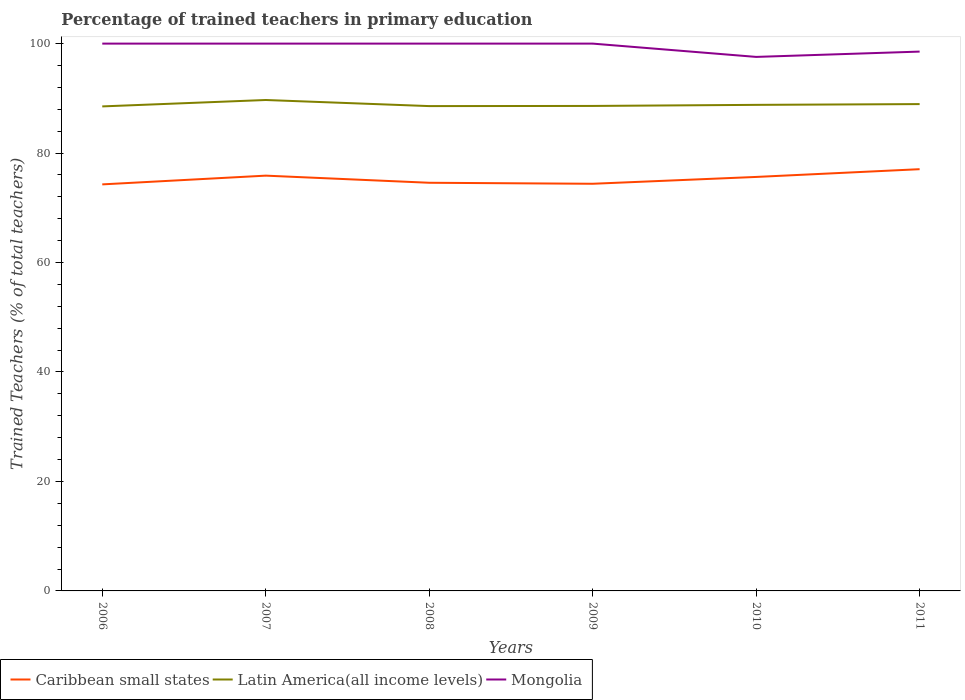Does the line corresponding to Latin America(all income levels) intersect with the line corresponding to Mongolia?
Make the answer very short. No. Across all years, what is the maximum percentage of trained teachers in Latin America(all income levels)?
Give a very brief answer. 88.53. What is the total percentage of trained teachers in Caribbean small states in the graph?
Your answer should be very brief. -1.6. What is the difference between the highest and the second highest percentage of trained teachers in Mongolia?
Ensure brevity in your answer.  2.43. Is the percentage of trained teachers in Latin America(all income levels) strictly greater than the percentage of trained teachers in Mongolia over the years?
Your response must be concise. Yes. How many lines are there?
Provide a succinct answer. 3. How many years are there in the graph?
Make the answer very short. 6. What is the difference between two consecutive major ticks on the Y-axis?
Make the answer very short. 20. Does the graph contain any zero values?
Your answer should be compact. No. How many legend labels are there?
Your answer should be very brief. 3. How are the legend labels stacked?
Your answer should be compact. Horizontal. What is the title of the graph?
Offer a very short reply. Percentage of trained teachers in primary education. Does "Bulgaria" appear as one of the legend labels in the graph?
Your response must be concise. No. What is the label or title of the Y-axis?
Ensure brevity in your answer.  Trained Teachers (% of total teachers). What is the Trained Teachers (% of total teachers) in Caribbean small states in 2006?
Provide a succinct answer. 74.28. What is the Trained Teachers (% of total teachers) of Latin America(all income levels) in 2006?
Provide a succinct answer. 88.53. What is the Trained Teachers (% of total teachers) in Caribbean small states in 2007?
Give a very brief answer. 75.88. What is the Trained Teachers (% of total teachers) in Latin America(all income levels) in 2007?
Your response must be concise. 89.7. What is the Trained Teachers (% of total teachers) in Caribbean small states in 2008?
Provide a succinct answer. 74.57. What is the Trained Teachers (% of total teachers) in Latin America(all income levels) in 2008?
Provide a short and direct response. 88.58. What is the Trained Teachers (% of total teachers) of Mongolia in 2008?
Your answer should be very brief. 100. What is the Trained Teachers (% of total teachers) of Caribbean small states in 2009?
Provide a short and direct response. 74.39. What is the Trained Teachers (% of total teachers) of Latin America(all income levels) in 2009?
Ensure brevity in your answer.  88.61. What is the Trained Teachers (% of total teachers) of Caribbean small states in 2010?
Provide a succinct answer. 75.64. What is the Trained Teachers (% of total teachers) of Latin America(all income levels) in 2010?
Provide a succinct answer. 88.81. What is the Trained Teachers (% of total teachers) in Mongolia in 2010?
Ensure brevity in your answer.  97.57. What is the Trained Teachers (% of total teachers) in Caribbean small states in 2011?
Your answer should be very brief. 77.06. What is the Trained Teachers (% of total teachers) of Latin America(all income levels) in 2011?
Your answer should be very brief. 88.95. What is the Trained Teachers (% of total teachers) in Mongolia in 2011?
Your answer should be compact. 98.54. Across all years, what is the maximum Trained Teachers (% of total teachers) in Caribbean small states?
Offer a terse response. 77.06. Across all years, what is the maximum Trained Teachers (% of total teachers) of Latin America(all income levels)?
Provide a short and direct response. 89.7. Across all years, what is the maximum Trained Teachers (% of total teachers) of Mongolia?
Provide a succinct answer. 100. Across all years, what is the minimum Trained Teachers (% of total teachers) of Caribbean small states?
Give a very brief answer. 74.28. Across all years, what is the minimum Trained Teachers (% of total teachers) of Latin America(all income levels)?
Provide a succinct answer. 88.53. Across all years, what is the minimum Trained Teachers (% of total teachers) of Mongolia?
Your answer should be very brief. 97.57. What is the total Trained Teachers (% of total teachers) of Caribbean small states in the graph?
Offer a terse response. 451.82. What is the total Trained Teachers (% of total teachers) of Latin America(all income levels) in the graph?
Your answer should be very brief. 533.18. What is the total Trained Teachers (% of total teachers) in Mongolia in the graph?
Ensure brevity in your answer.  596.11. What is the difference between the Trained Teachers (% of total teachers) of Caribbean small states in 2006 and that in 2007?
Provide a short and direct response. -1.6. What is the difference between the Trained Teachers (% of total teachers) of Latin America(all income levels) in 2006 and that in 2007?
Give a very brief answer. -1.17. What is the difference between the Trained Teachers (% of total teachers) in Mongolia in 2006 and that in 2007?
Make the answer very short. 0. What is the difference between the Trained Teachers (% of total teachers) of Caribbean small states in 2006 and that in 2008?
Your answer should be compact. -0.29. What is the difference between the Trained Teachers (% of total teachers) of Latin America(all income levels) in 2006 and that in 2008?
Give a very brief answer. -0.05. What is the difference between the Trained Teachers (% of total teachers) of Mongolia in 2006 and that in 2008?
Provide a short and direct response. 0. What is the difference between the Trained Teachers (% of total teachers) in Caribbean small states in 2006 and that in 2009?
Ensure brevity in your answer.  -0.11. What is the difference between the Trained Teachers (% of total teachers) in Latin America(all income levels) in 2006 and that in 2009?
Provide a short and direct response. -0.08. What is the difference between the Trained Teachers (% of total teachers) of Caribbean small states in 2006 and that in 2010?
Ensure brevity in your answer.  -1.36. What is the difference between the Trained Teachers (% of total teachers) of Latin America(all income levels) in 2006 and that in 2010?
Your answer should be compact. -0.28. What is the difference between the Trained Teachers (% of total teachers) in Mongolia in 2006 and that in 2010?
Provide a succinct answer. 2.43. What is the difference between the Trained Teachers (% of total teachers) in Caribbean small states in 2006 and that in 2011?
Keep it short and to the point. -2.78. What is the difference between the Trained Teachers (% of total teachers) of Latin America(all income levels) in 2006 and that in 2011?
Provide a succinct answer. -0.42. What is the difference between the Trained Teachers (% of total teachers) of Mongolia in 2006 and that in 2011?
Offer a very short reply. 1.46. What is the difference between the Trained Teachers (% of total teachers) of Caribbean small states in 2007 and that in 2008?
Make the answer very short. 1.3. What is the difference between the Trained Teachers (% of total teachers) in Latin America(all income levels) in 2007 and that in 2008?
Your answer should be compact. 1.11. What is the difference between the Trained Teachers (% of total teachers) in Mongolia in 2007 and that in 2008?
Provide a short and direct response. 0. What is the difference between the Trained Teachers (% of total teachers) of Caribbean small states in 2007 and that in 2009?
Ensure brevity in your answer.  1.48. What is the difference between the Trained Teachers (% of total teachers) of Latin America(all income levels) in 2007 and that in 2009?
Offer a very short reply. 1.08. What is the difference between the Trained Teachers (% of total teachers) in Mongolia in 2007 and that in 2009?
Your answer should be compact. 0. What is the difference between the Trained Teachers (% of total teachers) of Caribbean small states in 2007 and that in 2010?
Your answer should be very brief. 0.24. What is the difference between the Trained Teachers (% of total teachers) in Latin America(all income levels) in 2007 and that in 2010?
Ensure brevity in your answer.  0.89. What is the difference between the Trained Teachers (% of total teachers) of Mongolia in 2007 and that in 2010?
Offer a very short reply. 2.43. What is the difference between the Trained Teachers (% of total teachers) of Caribbean small states in 2007 and that in 2011?
Keep it short and to the point. -1.18. What is the difference between the Trained Teachers (% of total teachers) of Latin America(all income levels) in 2007 and that in 2011?
Your answer should be very brief. 0.75. What is the difference between the Trained Teachers (% of total teachers) of Mongolia in 2007 and that in 2011?
Make the answer very short. 1.46. What is the difference between the Trained Teachers (% of total teachers) in Caribbean small states in 2008 and that in 2009?
Offer a very short reply. 0.18. What is the difference between the Trained Teachers (% of total teachers) in Latin America(all income levels) in 2008 and that in 2009?
Give a very brief answer. -0.03. What is the difference between the Trained Teachers (% of total teachers) in Caribbean small states in 2008 and that in 2010?
Make the answer very short. -1.06. What is the difference between the Trained Teachers (% of total teachers) of Latin America(all income levels) in 2008 and that in 2010?
Make the answer very short. -0.23. What is the difference between the Trained Teachers (% of total teachers) of Mongolia in 2008 and that in 2010?
Offer a terse response. 2.43. What is the difference between the Trained Teachers (% of total teachers) in Caribbean small states in 2008 and that in 2011?
Your answer should be compact. -2.48. What is the difference between the Trained Teachers (% of total teachers) of Latin America(all income levels) in 2008 and that in 2011?
Your response must be concise. -0.37. What is the difference between the Trained Teachers (% of total teachers) in Mongolia in 2008 and that in 2011?
Provide a succinct answer. 1.46. What is the difference between the Trained Teachers (% of total teachers) in Caribbean small states in 2009 and that in 2010?
Your response must be concise. -1.25. What is the difference between the Trained Teachers (% of total teachers) of Latin America(all income levels) in 2009 and that in 2010?
Your response must be concise. -0.2. What is the difference between the Trained Teachers (% of total teachers) in Mongolia in 2009 and that in 2010?
Provide a short and direct response. 2.43. What is the difference between the Trained Teachers (% of total teachers) in Caribbean small states in 2009 and that in 2011?
Provide a succinct answer. -2.66. What is the difference between the Trained Teachers (% of total teachers) in Latin America(all income levels) in 2009 and that in 2011?
Give a very brief answer. -0.34. What is the difference between the Trained Teachers (% of total teachers) of Mongolia in 2009 and that in 2011?
Your answer should be compact. 1.46. What is the difference between the Trained Teachers (% of total teachers) of Caribbean small states in 2010 and that in 2011?
Offer a terse response. -1.42. What is the difference between the Trained Teachers (% of total teachers) in Latin America(all income levels) in 2010 and that in 2011?
Provide a succinct answer. -0.14. What is the difference between the Trained Teachers (% of total teachers) in Mongolia in 2010 and that in 2011?
Your response must be concise. -0.97. What is the difference between the Trained Teachers (% of total teachers) of Caribbean small states in 2006 and the Trained Teachers (% of total teachers) of Latin America(all income levels) in 2007?
Provide a succinct answer. -15.42. What is the difference between the Trained Teachers (% of total teachers) in Caribbean small states in 2006 and the Trained Teachers (% of total teachers) in Mongolia in 2007?
Your response must be concise. -25.72. What is the difference between the Trained Teachers (% of total teachers) in Latin America(all income levels) in 2006 and the Trained Teachers (% of total teachers) in Mongolia in 2007?
Make the answer very short. -11.47. What is the difference between the Trained Teachers (% of total teachers) of Caribbean small states in 2006 and the Trained Teachers (% of total teachers) of Latin America(all income levels) in 2008?
Offer a very short reply. -14.3. What is the difference between the Trained Teachers (% of total teachers) in Caribbean small states in 2006 and the Trained Teachers (% of total teachers) in Mongolia in 2008?
Give a very brief answer. -25.72. What is the difference between the Trained Teachers (% of total teachers) in Latin America(all income levels) in 2006 and the Trained Teachers (% of total teachers) in Mongolia in 2008?
Keep it short and to the point. -11.47. What is the difference between the Trained Teachers (% of total teachers) of Caribbean small states in 2006 and the Trained Teachers (% of total teachers) of Latin America(all income levels) in 2009?
Ensure brevity in your answer.  -14.33. What is the difference between the Trained Teachers (% of total teachers) in Caribbean small states in 2006 and the Trained Teachers (% of total teachers) in Mongolia in 2009?
Offer a very short reply. -25.72. What is the difference between the Trained Teachers (% of total teachers) of Latin America(all income levels) in 2006 and the Trained Teachers (% of total teachers) of Mongolia in 2009?
Offer a very short reply. -11.47. What is the difference between the Trained Teachers (% of total teachers) in Caribbean small states in 2006 and the Trained Teachers (% of total teachers) in Latin America(all income levels) in 2010?
Make the answer very short. -14.53. What is the difference between the Trained Teachers (% of total teachers) in Caribbean small states in 2006 and the Trained Teachers (% of total teachers) in Mongolia in 2010?
Your response must be concise. -23.29. What is the difference between the Trained Teachers (% of total teachers) of Latin America(all income levels) in 2006 and the Trained Teachers (% of total teachers) of Mongolia in 2010?
Provide a short and direct response. -9.04. What is the difference between the Trained Teachers (% of total teachers) in Caribbean small states in 2006 and the Trained Teachers (% of total teachers) in Latin America(all income levels) in 2011?
Your answer should be compact. -14.67. What is the difference between the Trained Teachers (% of total teachers) in Caribbean small states in 2006 and the Trained Teachers (% of total teachers) in Mongolia in 2011?
Your answer should be compact. -24.26. What is the difference between the Trained Teachers (% of total teachers) of Latin America(all income levels) in 2006 and the Trained Teachers (% of total teachers) of Mongolia in 2011?
Provide a succinct answer. -10.01. What is the difference between the Trained Teachers (% of total teachers) in Caribbean small states in 2007 and the Trained Teachers (% of total teachers) in Latin America(all income levels) in 2008?
Your answer should be compact. -12.7. What is the difference between the Trained Teachers (% of total teachers) in Caribbean small states in 2007 and the Trained Teachers (% of total teachers) in Mongolia in 2008?
Ensure brevity in your answer.  -24.12. What is the difference between the Trained Teachers (% of total teachers) of Latin America(all income levels) in 2007 and the Trained Teachers (% of total teachers) of Mongolia in 2008?
Your response must be concise. -10.3. What is the difference between the Trained Teachers (% of total teachers) in Caribbean small states in 2007 and the Trained Teachers (% of total teachers) in Latin America(all income levels) in 2009?
Your answer should be compact. -12.73. What is the difference between the Trained Teachers (% of total teachers) of Caribbean small states in 2007 and the Trained Teachers (% of total teachers) of Mongolia in 2009?
Offer a terse response. -24.12. What is the difference between the Trained Teachers (% of total teachers) in Latin America(all income levels) in 2007 and the Trained Teachers (% of total teachers) in Mongolia in 2009?
Ensure brevity in your answer.  -10.3. What is the difference between the Trained Teachers (% of total teachers) of Caribbean small states in 2007 and the Trained Teachers (% of total teachers) of Latin America(all income levels) in 2010?
Keep it short and to the point. -12.93. What is the difference between the Trained Teachers (% of total teachers) of Caribbean small states in 2007 and the Trained Teachers (% of total teachers) of Mongolia in 2010?
Give a very brief answer. -21.69. What is the difference between the Trained Teachers (% of total teachers) in Latin America(all income levels) in 2007 and the Trained Teachers (% of total teachers) in Mongolia in 2010?
Offer a terse response. -7.88. What is the difference between the Trained Teachers (% of total teachers) in Caribbean small states in 2007 and the Trained Teachers (% of total teachers) in Latin America(all income levels) in 2011?
Offer a terse response. -13.07. What is the difference between the Trained Teachers (% of total teachers) in Caribbean small states in 2007 and the Trained Teachers (% of total teachers) in Mongolia in 2011?
Ensure brevity in your answer.  -22.66. What is the difference between the Trained Teachers (% of total teachers) in Latin America(all income levels) in 2007 and the Trained Teachers (% of total teachers) in Mongolia in 2011?
Your response must be concise. -8.85. What is the difference between the Trained Teachers (% of total teachers) of Caribbean small states in 2008 and the Trained Teachers (% of total teachers) of Latin America(all income levels) in 2009?
Offer a very short reply. -14.04. What is the difference between the Trained Teachers (% of total teachers) in Caribbean small states in 2008 and the Trained Teachers (% of total teachers) in Mongolia in 2009?
Ensure brevity in your answer.  -25.43. What is the difference between the Trained Teachers (% of total teachers) of Latin America(all income levels) in 2008 and the Trained Teachers (% of total teachers) of Mongolia in 2009?
Your answer should be compact. -11.42. What is the difference between the Trained Teachers (% of total teachers) of Caribbean small states in 2008 and the Trained Teachers (% of total teachers) of Latin America(all income levels) in 2010?
Keep it short and to the point. -14.24. What is the difference between the Trained Teachers (% of total teachers) of Caribbean small states in 2008 and the Trained Teachers (% of total teachers) of Mongolia in 2010?
Give a very brief answer. -23. What is the difference between the Trained Teachers (% of total teachers) of Latin America(all income levels) in 2008 and the Trained Teachers (% of total teachers) of Mongolia in 2010?
Offer a very short reply. -8.99. What is the difference between the Trained Teachers (% of total teachers) of Caribbean small states in 2008 and the Trained Teachers (% of total teachers) of Latin America(all income levels) in 2011?
Your answer should be very brief. -14.38. What is the difference between the Trained Teachers (% of total teachers) of Caribbean small states in 2008 and the Trained Teachers (% of total teachers) of Mongolia in 2011?
Your answer should be very brief. -23.97. What is the difference between the Trained Teachers (% of total teachers) in Latin America(all income levels) in 2008 and the Trained Teachers (% of total teachers) in Mongolia in 2011?
Provide a succinct answer. -9.96. What is the difference between the Trained Teachers (% of total teachers) in Caribbean small states in 2009 and the Trained Teachers (% of total teachers) in Latin America(all income levels) in 2010?
Ensure brevity in your answer.  -14.42. What is the difference between the Trained Teachers (% of total teachers) in Caribbean small states in 2009 and the Trained Teachers (% of total teachers) in Mongolia in 2010?
Your answer should be compact. -23.18. What is the difference between the Trained Teachers (% of total teachers) of Latin America(all income levels) in 2009 and the Trained Teachers (% of total teachers) of Mongolia in 2010?
Offer a terse response. -8.96. What is the difference between the Trained Teachers (% of total teachers) in Caribbean small states in 2009 and the Trained Teachers (% of total teachers) in Latin America(all income levels) in 2011?
Your answer should be compact. -14.56. What is the difference between the Trained Teachers (% of total teachers) in Caribbean small states in 2009 and the Trained Teachers (% of total teachers) in Mongolia in 2011?
Give a very brief answer. -24.15. What is the difference between the Trained Teachers (% of total teachers) of Latin America(all income levels) in 2009 and the Trained Teachers (% of total teachers) of Mongolia in 2011?
Your answer should be compact. -9.93. What is the difference between the Trained Teachers (% of total teachers) in Caribbean small states in 2010 and the Trained Teachers (% of total teachers) in Latin America(all income levels) in 2011?
Your answer should be very brief. -13.31. What is the difference between the Trained Teachers (% of total teachers) in Caribbean small states in 2010 and the Trained Teachers (% of total teachers) in Mongolia in 2011?
Your answer should be compact. -22.9. What is the difference between the Trained Teachers (% of total teachers) of Latin America(all income levels) in 2010 and the Trained Teachers (% of total teachers) of Mongolia in 2011?
Make the answer very short. -9.73. What is the average Trained Teachers (% of total teachers) of Caribbean small states per year?
Offer a very short reply. 75.3. What is the average Trained Teachers (% of total teachers) of Latin America(all income levels) per year?
Keep it short and to the point. 88.86. What is the average Trained Teachers (% of total teachers) of Mongolia per year?
Give a very brief answer. 99.35. In the year 2006, what is the difference between the Trained Teachers (% of total teachers) in Caribbean small states and Trained Teachers (% of total teachers) in Latin America(all income levels)?
Your answer should be compact. -14.25. In the year 2006, what is the difference between the Trained Teachers (% of total teachers) of Caribbean small states and Trained Teachers (% of total teachers) of Mongolia?
Make the answer very short. -25.72. In the year 2006, what is the difference between the Trained Teachers (% of total teachers) of Latin America(all income levels) and Trained Teachers (% of total teachers) of Mongolia?
Keep it short and to the point. -11.47. In the year 2007, what is the difference between the Trained Teachers (% of total teachers) of Caribbean small states and Trained Teachers (% of total teachers) of Latin America(all income levels)?
Your response must be concise. -13.82. In the year 2007, what is the difference between the Trained Teachers (% of total teachers) in Caribbean small states and Trained Teachers (% of total teachers) in Mongolia?
Give a very brief answer. -24.12. In the year 2007, what is the difference between the Trained Teachers (% of total teachers) of Latin America(all income levels) and Trained Teachers (% of total teachers) of Mongolia?
Keep it short and to the point. -10.3. In the year 2008, what is the difference between the Trained Teachers (% of total teachers) in Caribbean small states and Trained Teachers (% of total teachers) in Latin America(all income levels)?
Make the answer very short. -14.01. In the year 2008, what is the difference between the Trained Teachers (% of total teachers) of Caribbean small states and Trained Teachers (% of total teachers) of Mongolia?
Keep it short and to the point. -25.43. In the year 2008, what is the difference between the Trained Teachers (% of total teachers) of Latin America(all income levels) and Trained Teachers (% of total teachers) of Mongolia?
Offer a very short reply. -11.42. In the year 2009, what is the difference between the Trained Teachers (% of total teachers) of Caribbean small states and Trained Teachers (% of total teachers) of Latin America(all income levels)?
Offer a very short reply. -14.22. In the year 2009, what is the difference between the Trained Teachers (% of total teachers) in Caribbean small states and Trained Teachers (% of total teachers) in Mongolia?
Keep it short and to the point. -25.61. In the year 2009, what is the difference between the Trained Teachers (% of total teachers) of Latin America(all income levels) and Trained Teachers (% of total teachers) of Mongolia?
Provide a short and direct response. -11.39. In the year 2010, what is the difference between the Trained Teachers (% of total teachers) of Caribbean small states and Trained Teachers (% of total teachers) of Latin America(all income levels)?
Keep it short and to the point. -13.17. In the year 2010, what is the difference between the Trained Teachers (% of total teachers) in Caribbean small states and Trained Teachers (% of total teachers) in Mongolia?
Make the answer very short. -21.93. In the year 2010, what is the difference between the Trained Teachers (% of total teachers) of Latin America(all income levels) and Trained Teachers (% of total teachers) of Mongolia?
Offer a terse response. -8.76. In the year 2011, what is the difference between the Trained Teachers (% of total teachers) of Caribbean small states and Trained Teachers (% of total teachers) of Latin America(all income levels)?
Your answer should be compact. -11.89. In the year 2011, what is the difference between the Trained Teachers (% of total teachers) in Caribbean small states and Trained Teachers (% of total teachers) in Mongolia?
Keep it short and to the point. -21.49. In the year 2011, what is the difference between the Trained Teachers (% of total teachers) of Latin America(all income levels) and Trained Teachers (% of total teachers) of Mongolia?
Make the answer very short. -9.59. What is the ratio of the Trained Teachers (% of total teachers) in Caribbean small states in 2006 to that in 2007?
Provide a short and direct response. 0.98. What is the ratio of the Trained Teachers (% of total teachers) of Mongolia in 2006 to that in 2008?
Give a very brief answer. 1. What is the ratio of the Trained Teachers (% of total teachers) of Latin America(all income levels) in 2006 to that in 2009?
Offer a terse response. 1. What is the ratio of the Trained Teachers (% of total teachers) in Mongolia in 2006 to that in 2009?
Your answer should be compact. 1. What is the ratio of the Trained Teachers (% of total teachers) of Caribbean small states in 2006 to that in 2010?
Offer a very short reply. 0.98. What is the ratio of the Trained Teachers (% of total teachers) in Mongolia in 2006 to that in 2010?
Give a very brief answer. 1.02. What is the ratio of the Trained Teachers (% of total teachers) in Caribbean small states in 2006 to that in 2011?
Provide a short and direct response. 0.96. What is the ratio of the Trained Teachers (% of total teachers) of Mongolia in 2006 to that in 2011?
Make the answer very short. 1.01. What is the ratio of the Trained Teachers (% of total teachers) in Caribbean small states in 2007 to that in 2008?
Your response must be concise. 1.02. What is the ratio of the Trained Teachers (% of total teachers) of Latin America(all income levels) in 2007 to that in 2008?
Offer a very short reply. 1.01. What is the ratio of the Trained Teachers (% of total teachers) of Latin America(all income levels) in 2007 to that in 2009?
Provide a succinct answer. 1.01. What is the ratio of the Trained Teachers (% of total teachers) in Mongolia in 2007 to that in 2009?
Provide a succinct answer. 1. What is the ratio of the Trained Teachers (% of total teachers) in Caribbean small states in 2007 to that in 2010?
Provide a succinct answer. 1. What is the ratio of the Trained Teachers (% of total teachers) in Mongolia in 2007 to that in 2010?
Your answer should be compact. 1.02. What is the ratio of the Trained Teachers (% of total teachers) of Caribbean small states in 2007 to that in 2011?
Your answer should be very brief. 0.98. What is the ratio of the Trained Teachers (% of total teachers) in Latin America(all income levels) in 2007 to that in 2011?
Offer a very short reply. 1.01. What is the ratio of the Trained Teachers (% of total teachers) of Mongolia in 2007 to that in 2011?
Offer a terse response. 1.01. What is the ratio of the Trained Teachers (% of total teachers) of Caribbean small states in 2008 to that in 2010?
Make the answer very short. 0.99. What is the ratio of the Trained Teachers (% of total teachers) in Mongolia in 2008 to that in 2010?
Offer a very short reply. 1.02. What is the ratio of the Trained Teachers (% of total teachers) in Caribbean small states in 2008 to that in 2011?
Your answer should be compact. 0.97. What is the ratio of the Trained Teachers (% of total teachers) of Latin America(all income levels) in 2008 to that in 2011?
Offer a very short reply. 1. What is the ratio of the Trained Teachers (% of total teachers) in Mongolia in 2008 to that in 2011?
Make the answer very short. 1.01. What is the ratio of the Trained Teachers (% of total teachers) in Caribbean small states in 2009 to that in 2010?
Offer a very short reply. 0.98. What is the ratio of the Trained Teachers (% of total teachers) of Mongolia in 2009 to that in 2010?
Make the answer very short. 1.02. What is the ratio of the Trained Teachers (% of total teachers) in Caribbean small states in 2009 to that in 2011?
Offer a terse response. 0.97. What is the ratio of the Trained Teachers (% of total teachers) in Latin America(all income levels) in 2009 to that in 2011?
Keep it short and to the point. 1. What is the ratio of the Trained Teachers (% of total teachers) in Mongolia in 2009 to that in 2011?
Your answer should be compact. 1.01. What is the ratio of the Trained Teachers (% of total teachers) in Caribbean small states in 2010 to that in 2011?
Ensure brevity in your answer.  0.98. What is the difference between the highest and the second highest Trained Teachers (% of total teachers) of Caribbean small states?
Provide a short and direct response. 1.18. What is the difference between the highest and the second highest Trained Teachers (% of total teachers) in Latin America(all income levels)?
Offer a very short reply. 0.75. What is the difference between the highest and the lowest Trained Teachers (% of total teachers) of Caribbean small states?
Your answer should be very brief. 2.78. What is the difference between the highest and the lowest Trained Teachers (% of total teachers) of Latin America(all income levels)?
Make the answer very short. 1.17. What is the difference between the highest and the lowest Trained Teachers (% of total teachers) of Mongolia?
Provide a succinct answer. 2.43. 